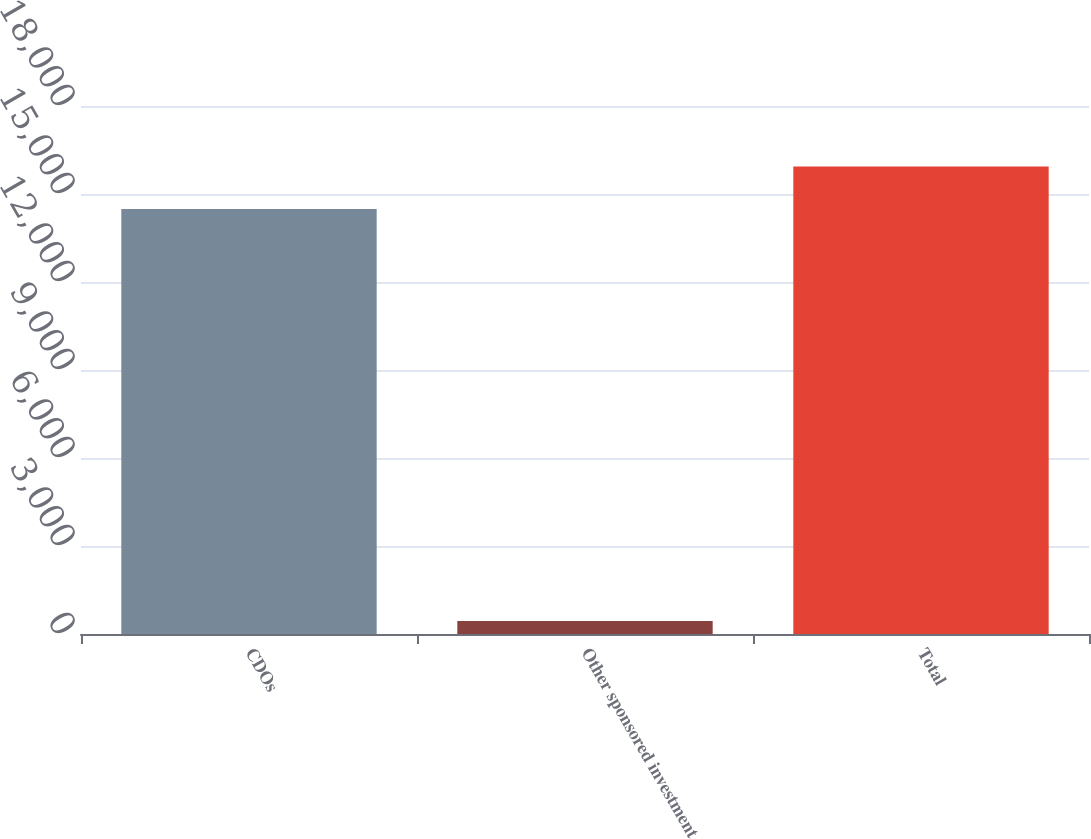<chart> <loc_0><loc_0><loc_500><loc_500><bar_chart><fcel>CDOs<fcel>Other sponsored investment<fcel>Total<nl><fcel>14487<fcel>440<fcel>15935.7<nl></chart> 